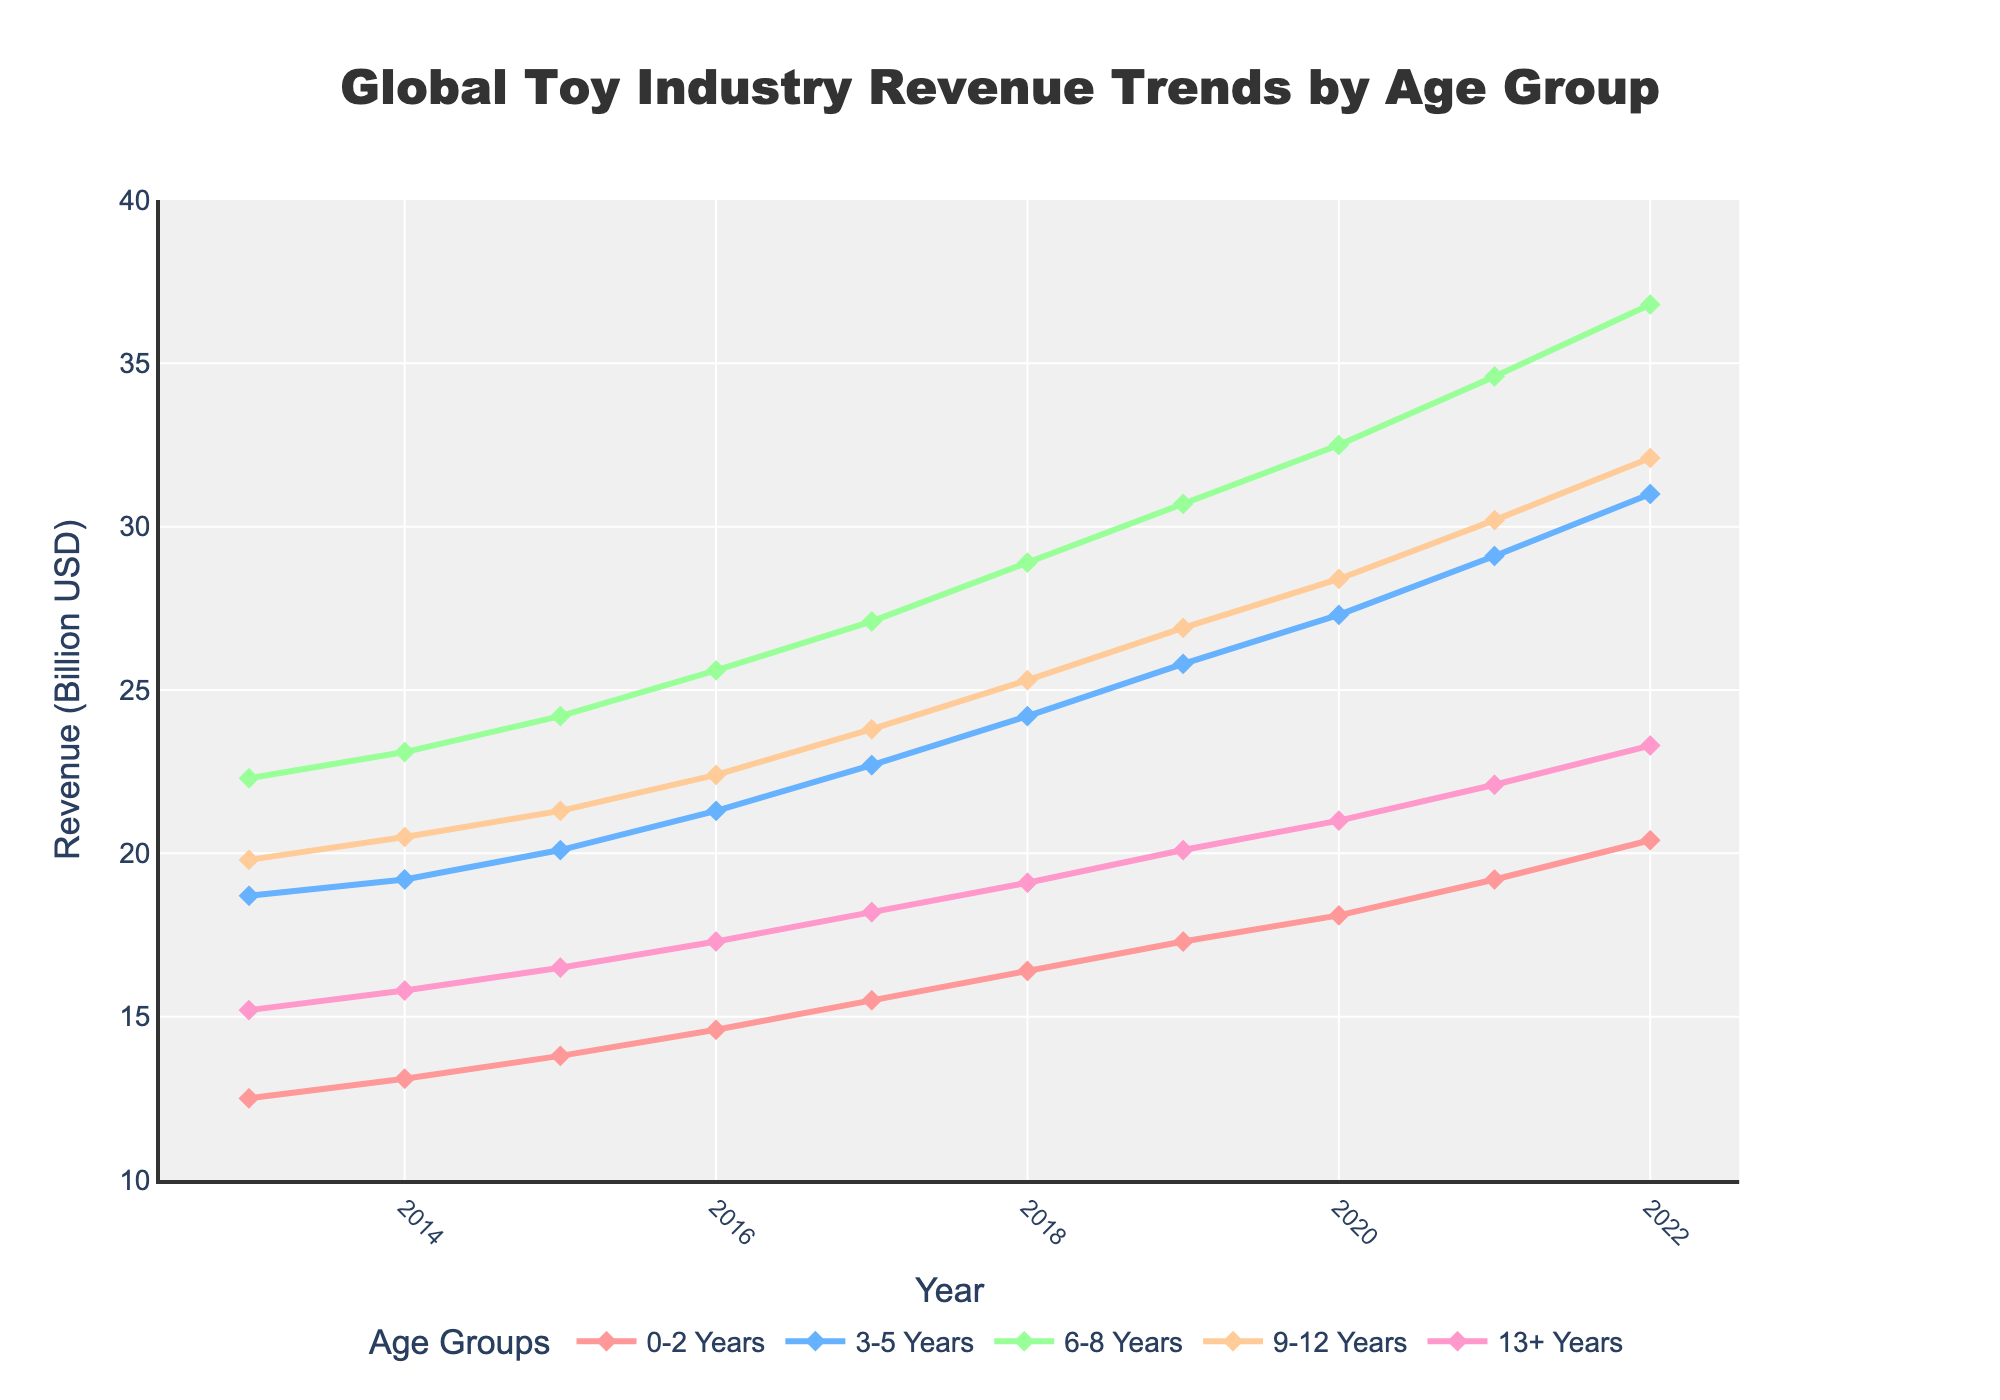What's the trend of revenue for the 9-12 years age group from 2013 to 2022? Observe the line representing the 9-12 years age group. The trend shows a continuous increase from 19.8 billion USD in 2013 to 32.1 billion USD in 2022.
Answer: An increasing trend Which age group had the highest revenue in 2016? Compare the values for the year 2016 across all age groups. The largest value is 25.6 billion USD, which belongs to the 6-8 years age group.
Answer: 6-8 years What is the total toy industry revenue across all age groups in 2022? Sum up the revenue values for all age groups for the year 2022: 20.4 (0-2 years) + 31.0 (3-5 years) + 36.8 (6-8 years) + 32.1 (9-12 years) + 23.3 (13+ years). 20.4 + 31.0 + 36.8 + 32.1 + 23.3 = 143.6 billion USD.
Answer: 143.6 billion USD Which age group experienced the largest increase in revenue from 2018 to 2020? Calculate the change in revenue from 2018 to 2020 for each age group. (18.1 - 16.4) for 0-2 years = 1.7, (27.3 - 24.2) for 3-5 years = 3.1, (32.5 - 28.9) for 6-8 years = 3.6, (28.4 - 25.3) for 9-12 years = 3.1, (21.0 - 19.1) for 13+ years = 1.9. The largest increase is 3.6 billion USD for the 6-8 years age group.
Answer: 6-8 years What is the average revenue for the 3-5 years age group over the decade? Sum the values for the 3-5 years age group from 2013 to 2022 and divide by the number of years (10). The sum is 18.7 + 19.2 + 20.1 + 21.3 + 22.7 + 24.2 + 25.8 + 27.3 + 29.1 + 31.0 = 239.4. So, the average is 239.4 / 10 = 23.94 billion USD.
Answer: 23.94 billion USD Which age group's revenue surpassed 20 billion USD first and in which year? Check the year each age group first surpassed 20 billion USD. For 6-8 years: 2013 (22.3). For other groups: 13+ years (2021), 9-12 years (2020), 3-5 years (2021), 0-2 years (2021). 6-8 years did so first in 2013.
Answer: 6-8 years in 2013 Which age group had the slowest revenue growth rate from 2013 to 2022? Determine the growth from 2013 to 2022 for each age group and compare them. For 0-2 years: 20.4 - 12.5 = 7.9. For 3-5 years: 31.0 - 18.7 = 12.3. For 6-8 years: 36.8 - 22.3 = 14.5. For 9-12 years: 32.1 - 19.8 = 12.3. For 13+ years: 23.3 - 15.2 = 8.1. The slowest growth is for the 0-2 years age group with an increase of 7.9 billion USD.
Answer: 0-2 years How does the revenue for 13+ years in 2022 compare with that in 2013? Look at the revenue values for the 13+ years age group in 2013 and 2022. 2013: 15.2 billion USD. 2022: 23.3 billion USD. The revenue increased from 15.2 to 23.3 billion USD.
Answer: Increased What is the difference between the highest and lowest revenue observed for any age group in 2022? Identify the highest and lowest revenues for 2022: highest is 36.8 (6-8 years) and lowest is 20.4 (0-2 years). Calculate the difference: 36.8 - 20.4 = 16.4 billion USD.
Answer: 16.4 billion USD 